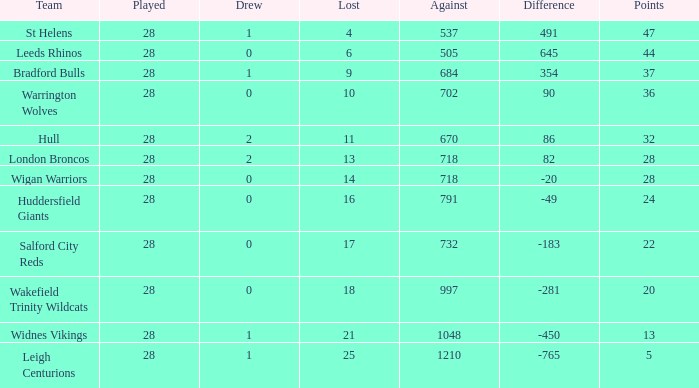Parse the table in full. {'header': ['Team', 'Played', 'Drew', 'Lost', 'Against', 'Difference', 'Points'], 'rows': [['St Helens', '28', '1', '4', '537', '491', '47'], ['Leeds Rhinos', '28', '0', '6', '505', '645', '44'], ['Bradford Bulls', '28', '1', '9', '684', '354', '37'], ['Warrington Wolves', '28', '0', '10', '702', '90', '36'], ['Hull', '28', '2', '11', '670', '86', '32'], ['London Broncos', '28', '2', '13', '718', '82', '28'], ['Wigan Warriors', '28', '0', '14', '718', '-20', '28'], ['Huddersfield Giants', '28', '0', '16', '791', '-49', '24'], ['Salford City Reds', '28', '0', '17', '732', '-183', '22'], ['Wakefield Trinity Wildcats', '28', '0', '18', '997', '-281', '20'], ['Widnes Vikings', '28', '1', '21', '1048', '-450', '13'], ['Leigh Centurions', '28', '1', '25', '1210', '-765', '5']]} What is the maximum disparity for the team that had fewer than 0 draws? None. 